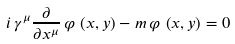Convert formula to latex. <formula><loc_0><loc_0><loc_500><loc_500>i \, \gamma ^ { \mu } \frac { \partial } { \partial x ^ { \mu } } \, \varphi \, \left ( x , y \right ) - m \, \varphi \, \left ( x , y \right ) = 0</formula> 